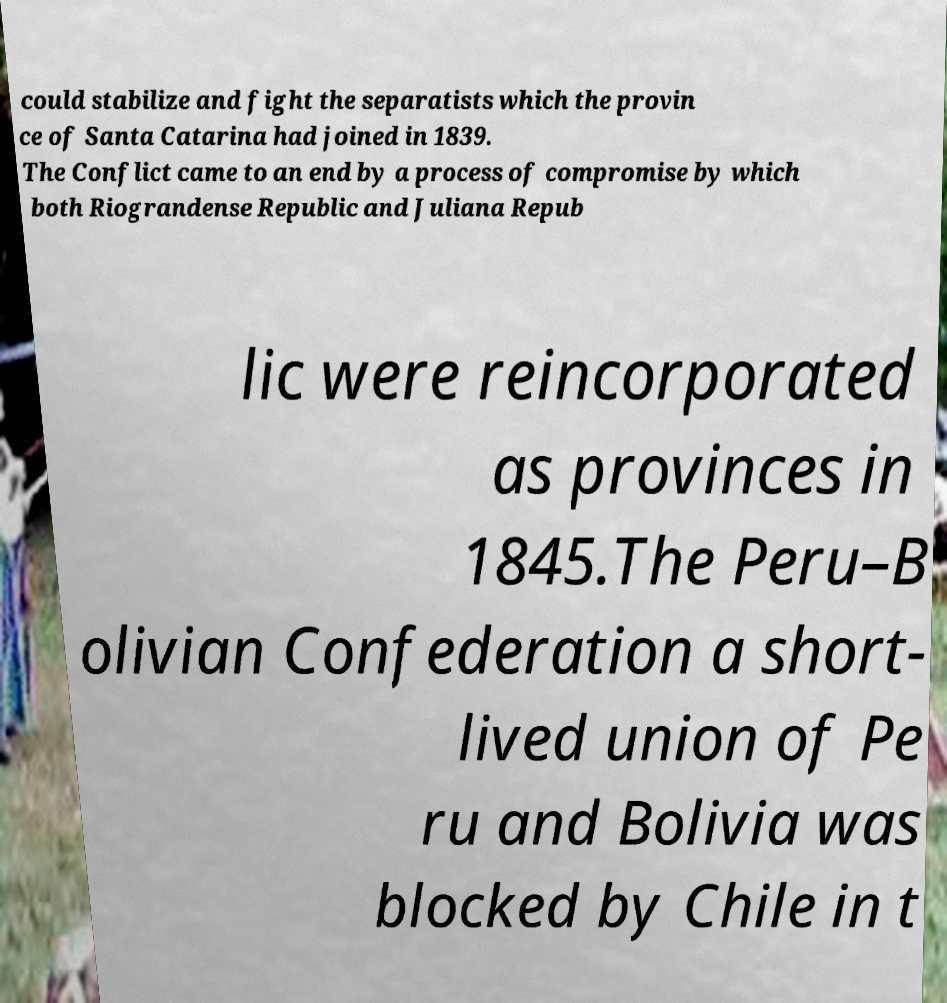I need the written content from this picture converted into text. Can you do that? could stabilize and fight the separatists which the provin ce of Santa Catarina had joined in 1839. The Conflict came to an end by a process of compromise by which both Riograndense Republic and Juliana Repub lic were reincorporated as provinces in 1845.The Peru–B olivian Confederation a short- lived union of Pe ru and Bolivia was blocked by Chile in t 